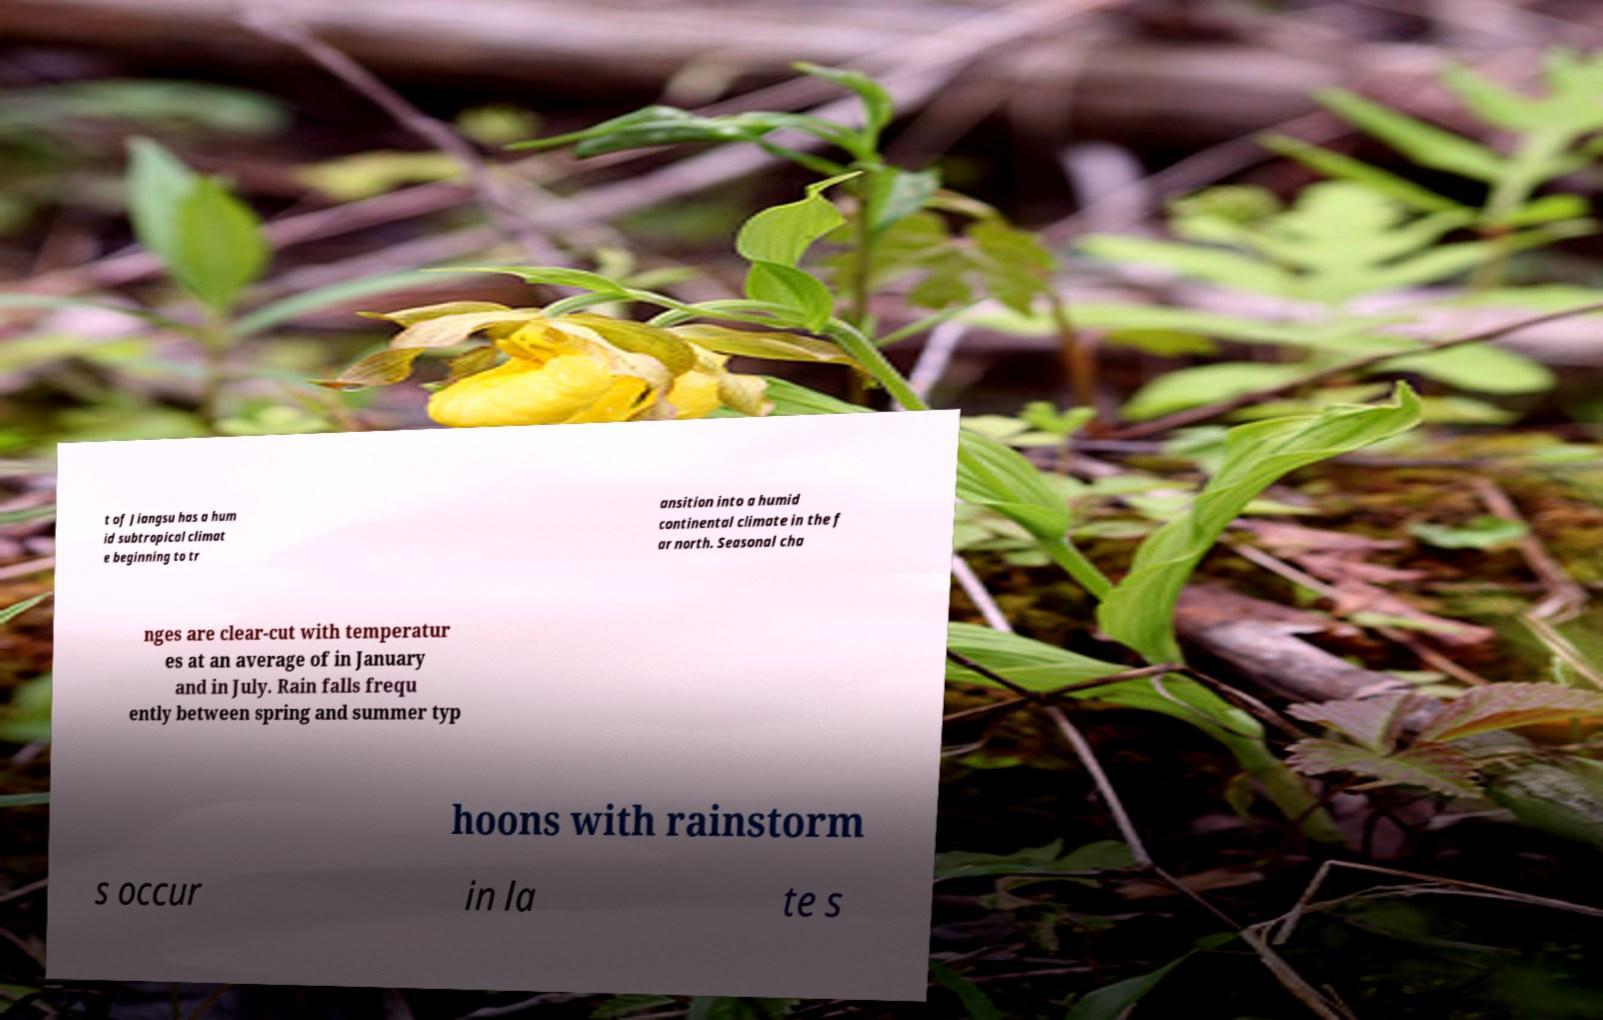Could you extract and type out the text from this image? t of Jiangsu has a hum id subtropical climat e beginning to tr ansition into a humid continental climate in the f ar north. Seasonal cha nges are clear-cut with temperatur es at an average of in January and in July. Rain falls frequ ently between spring and summer typ hoons with rainstorm s occur in la te s 